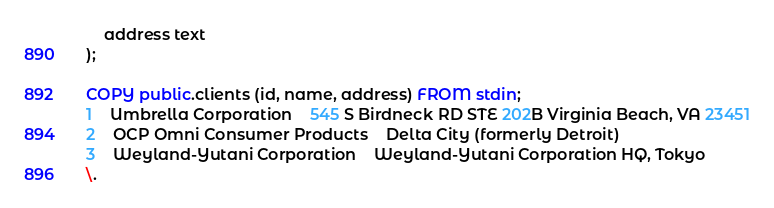<code> <loc_0><loc_0><loc_500><loc_500><_SQL_>    address text
);

COPY public.clients (id, name, address) FROM stdin;
1	Umbrella Corporation	545 S Birdneck RD STE 202B Virginia Beach, VA 23451
2	OCP Omni Consumer Products	Delta City (formerly Detroit) 
3	Weyland-Yutani Corporation	Weyland-Yutani Corporation HQ, Tokyo
\.
</code> 